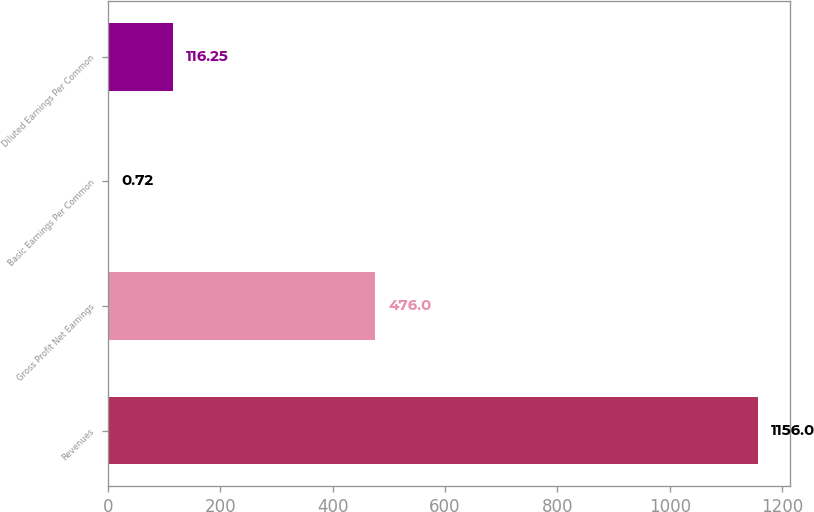Convert chart. <chart><loc_0><loc_0><loc_500><loc_500><bar_chart><fcel>Revenues<fcel>Gross Profit Net Earnings<fcel>Basic Earnings Per Common<fcel>Diluted Earnings Per Common<nl><fcel>1156<fcel>476<fcel>0.72<fcel>116.25<nl></chart> 